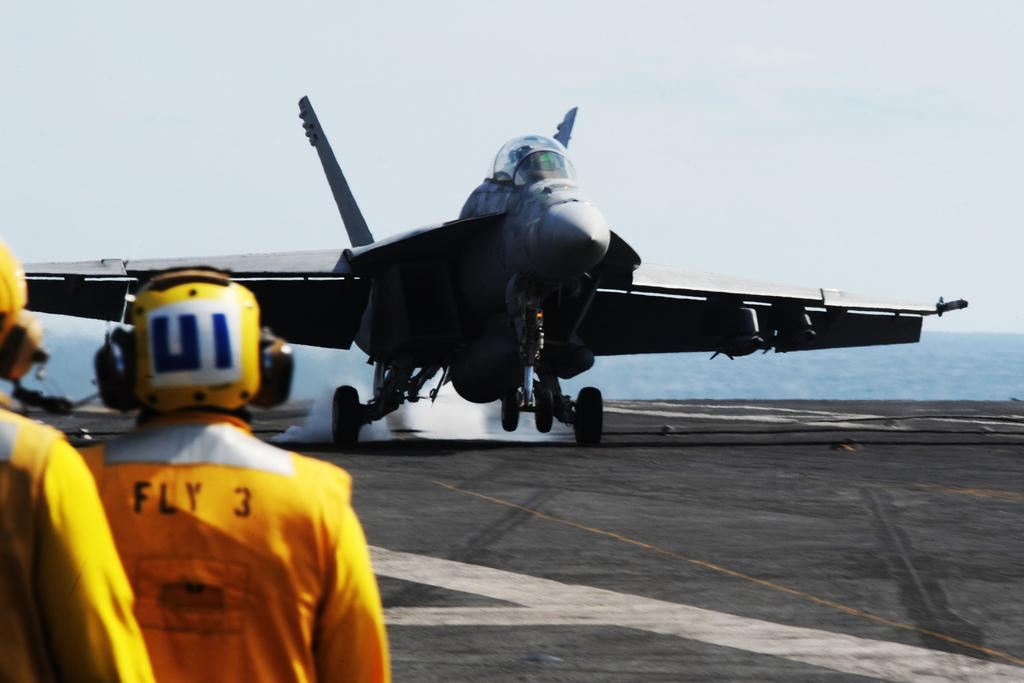Provide a one-sentence caption for the provided image. people wearing orange jumpsuits saying Fly 3 watch a plane land. 